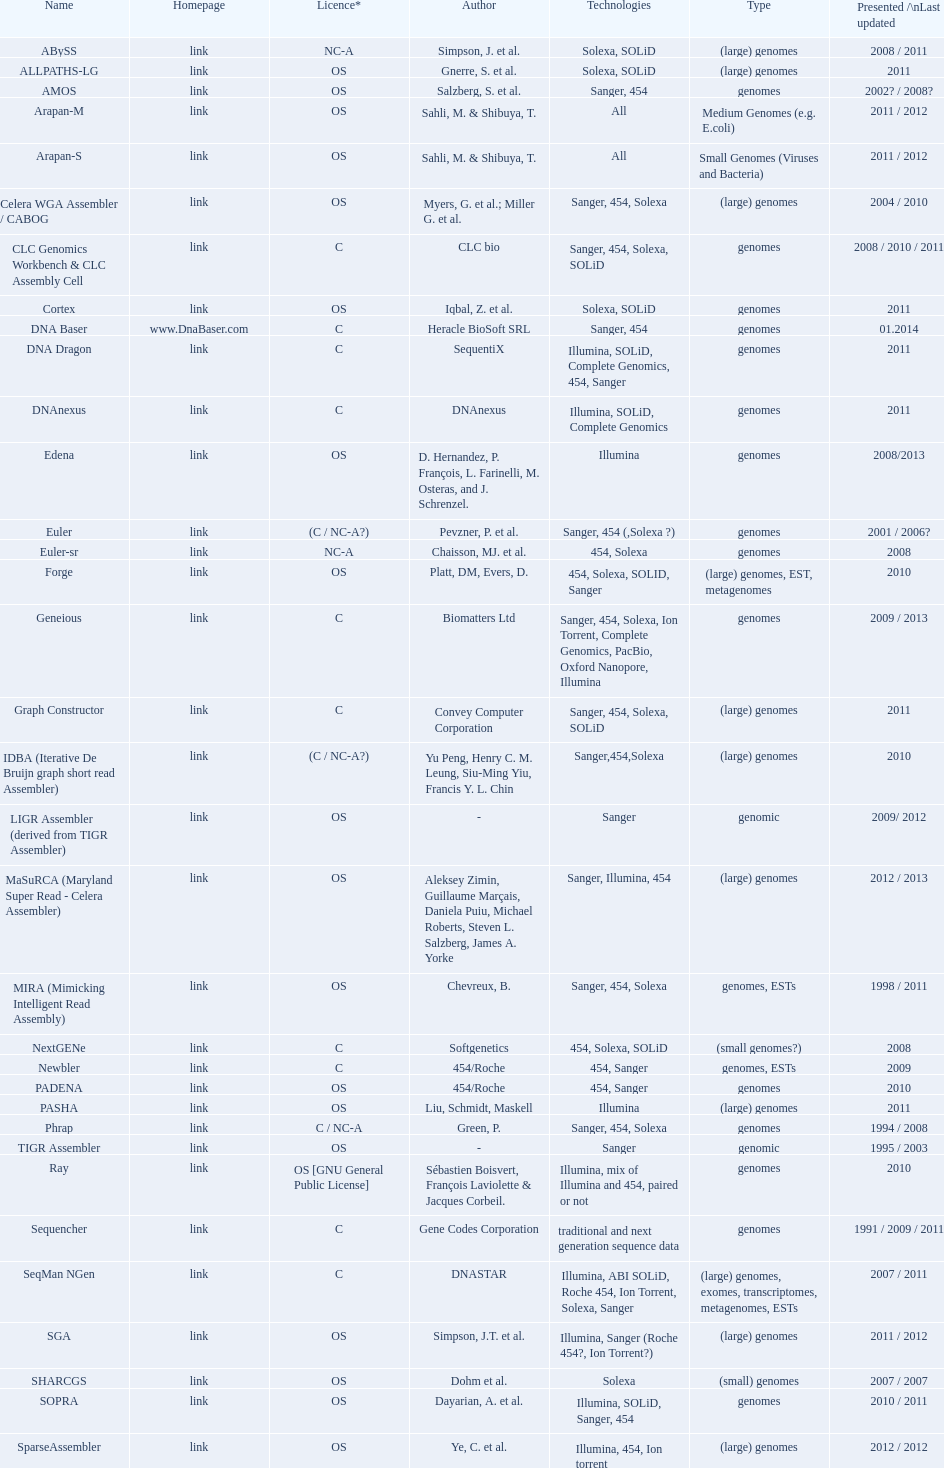What is the count of "all" technologies listed? 2. 